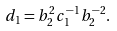<formula> <loc_0><loc_0><loc_500><loc_500>d _ { 1 } = b _ { 2 } ^ { 2 } c _ { 1 } ^ { - 1 } b _ { 2 } ^ { - 2 } .</formula> 